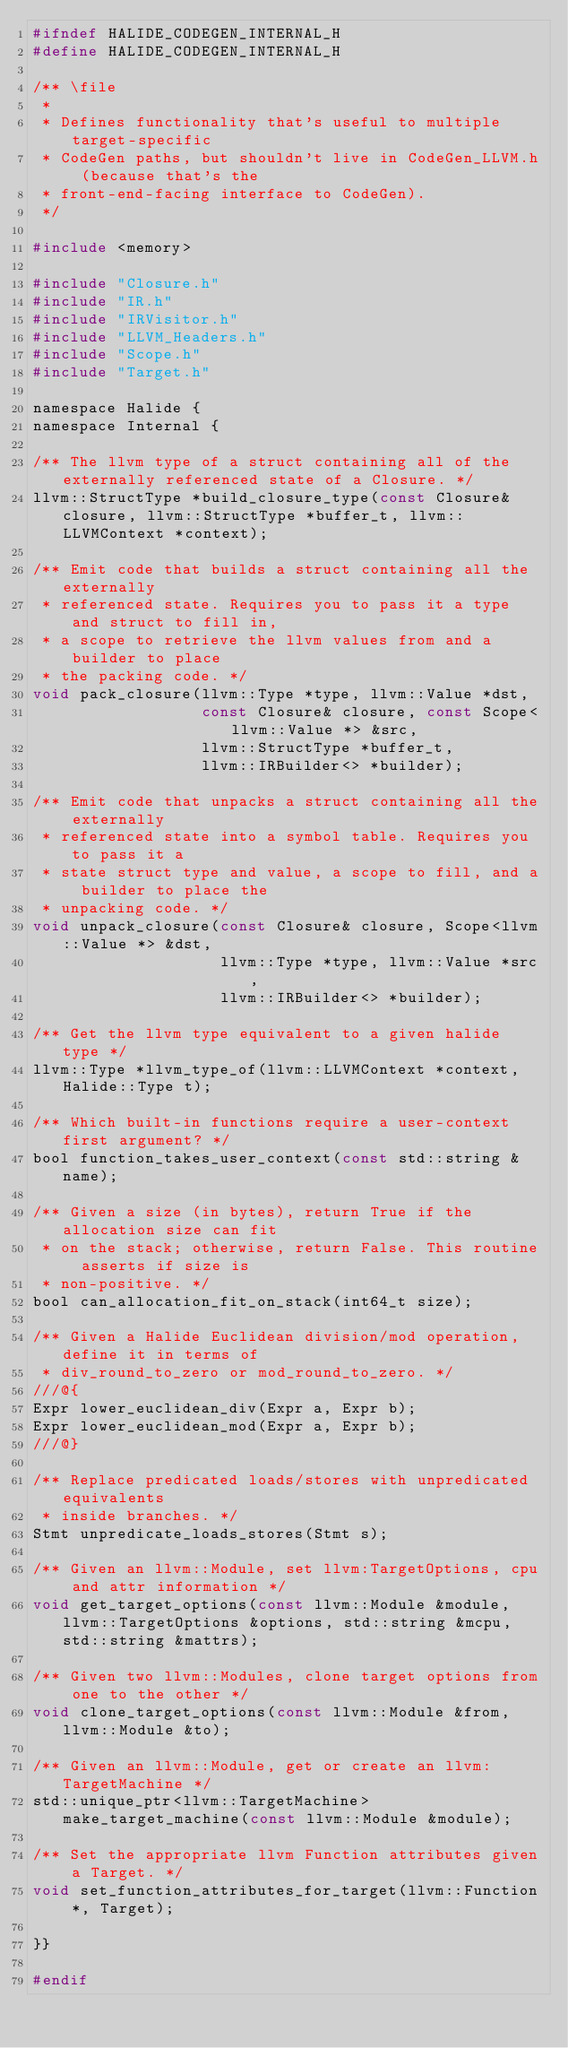Convert code to text. <code><loc_0><loc_0><loc_500><loc_500><_C_>#ifndef HALIDE_CODEGEN_INTERNAL_H
#define HALIDE_CODEGEN_INTERNAL_H

/** \file
 *
 * Defines functionality that's useful to multiple target-specific
 * CodeGen paths, but shouldn't live in CodeGen_LLVM.h (because that's the
 * front-end-facing interface to CodeGen).
 */

#include <memory>

#include "Closure.h"
#include "IR.h"
#include "IRVisitor.h"
#include "LLVM_Headers.h"
#include "Scope.h"
#include "Target.h"

namespace Halide {
namespace Internal {

/** The llvm type of a struct containing all of the externally referenced state of a Closure. */
llvm::StructType *build_closure_type(const Closure& closure, llvm::StructType *buffer_t, llvm::LLVMContext *context);

/** Emit code that builds a struct containing all the externally
 * referenced state. Requires you to pass it a type and struct to fill in,
 * a scope to retrieve the llvm values from and a builder to place
 * the packing code. */
void pack_closure(llvm::Type *type, llvm::Value *dst,
                  const Closure& closure, const Scope<llvm::Value *> &src,
                  llvm::StructType *buffer_t,
                  llvm::IRBuilder<> *builder);

/** Emit code that unpacks a struct containing all the externally
 * referenced state into a symbol table. Requires you to pass it a
 * state struct type and value, a scope to fill, and a builder to place the
 * unpacking code. */
void unpack_closure(const Closure& closure, Scope<llvm::Value *> &dst,
                    llvm::Type *type, llvm::Value *src,
                    llvm::IRBuilder<> *builder);

/** Get the llvm type equivalent to a given halide type */
llvm::Type *llvm_type_of(llvm::LLVMContext *context, Halide::Type t);

/** Which built-in functions require a user-context first argument? */
bool function_takes_user_context(const std::string &name);

/** Given a size (in bytes), return True if the allocation size can fit
 * on the stack; otherwise, return False. This routine asserts if size is
 * non-positive. */
bool can_allocation_fit_on_stack(int64_t size);

/** Given a Halide Euclidean division/mod operation, define it in terms of
 * div_round_to_zero or mod_round_to_zero. */
///@{
Expr lower_euclidean_div(Expr a, Expr b);
Expr lower_euclidean_mod(Expr a, Expr b);
///@}

/** Replace predicated loads/stores with unpredicated equivalents
 * inside branches. */
Stmt unpredicate_loads_stores(Stmt s);

/** Given an llvm::Module, set llvm:TargetOptions, cpu and attr information */
void get_target_options(const llvm::Module &module, llvm::TargetOptions &options, std::string &mcpu, std::string &mattrs);

/** Given two llvm::Modules, clone target options from one to the other */
void clone_target_options(const llvm::Module &from, llvm::Module &to);

/** Given an llvm::Module, get or create an llvm:TargetMachine */
std::unique_ptr<llvm::TargetMachine> make_target_machine(const llvm::Module &module);

/** Set the appropriate llvm Function attributes given a Target. */
void set_function_attributes_for_target(llvm::Function *, Target);

}}

#endif
</code> 